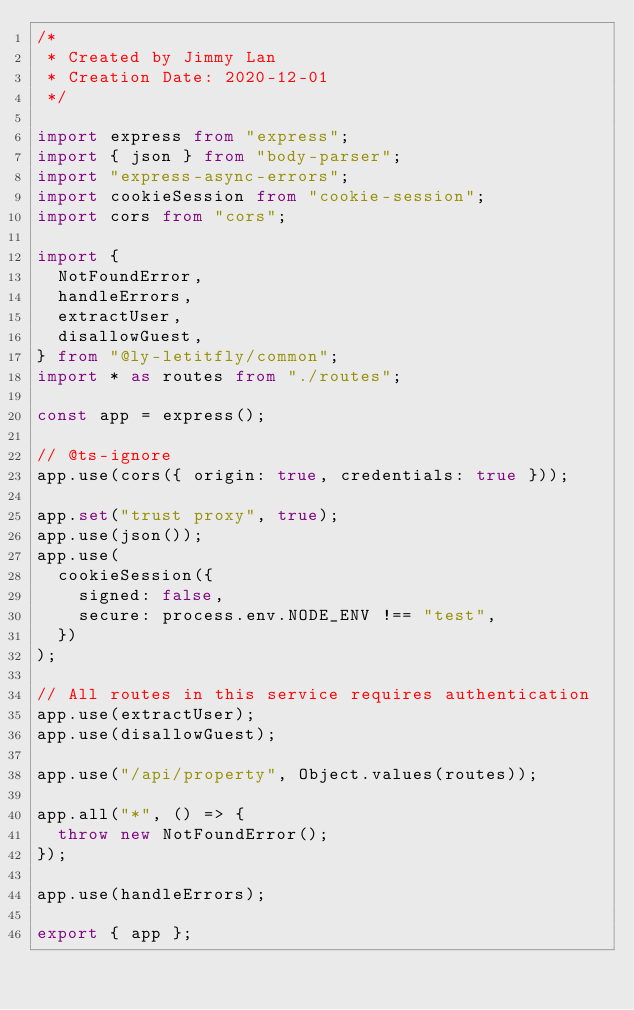<code> <loc_0><loc_0><loc_500><loc_500><_TypeScript_>/*
 * Created by Jimmy Lan
 * Creation Date: 2020-12-01
 */

import express from "express";
import { json } from "body-parser";
import "express-async-errors";
import cookieSession from "cookie-session";
import cors from "cors";

import {
  NotFoundError,
  handleErrors,
  extractUser,
  disallowGuest,
} from "@ly-letitfly/common";
import * as routes from "./routes";

const app = express();

// @ts-ignore
app.use(cors({ origin: true, credentials: true }));

app.set("trust proxy", true);
app.use(json());
app.use(
  cookieSession({
    signed: false,
    secure: process.env.NODE_ENV !== "test",
  })
);

// All routes in this service requires authentication
app.use(extractUser);
app.use(disallowGuest);

app.use("/api/property", Object.values(routes));

app.all("*", () => {
  throw new NotFoundError();
});

app.use(handleErrors);

export { app };
</code> 